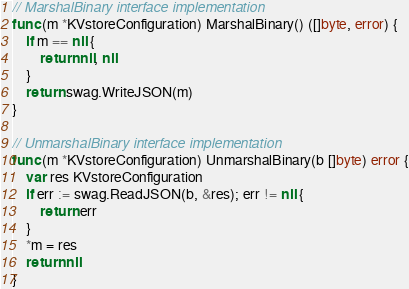Convert code to text. <code><loc_0><loc_0><loc_500><loc_500><_Go_>// MarshalBinary interface implementation
func (m *KVstoreConfiguration) MarshalBinary() ([]byte, error) {
	if m == nil {
		return nil, nil
	}
	return swag.WriteJSON(m)
}

// UnmarshalBinary interface implementation
func (m *KVstoreConfiguration) UnmarshalBinary(b []byte) error {
	var res KVstoreConfiguration
	if err := swag.ReadJSON(b, &res); err != nil {
		return err
	}
	*m = res
	return nil
}
</code> 